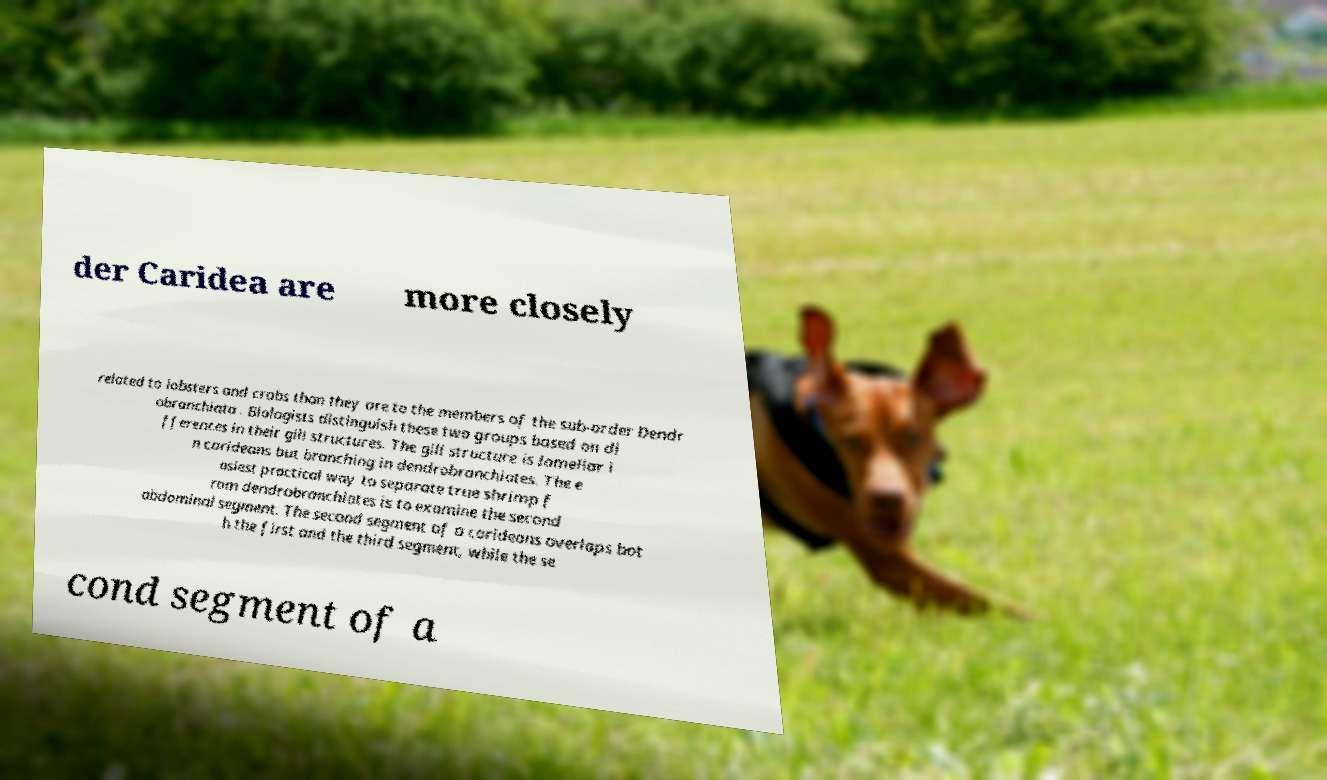For documentation purposes, I need the text within this image transcribed. Could you provide that? der Caridea are more closely related to lobsters and crabs than they are to the members of the sub-order Dendr obranchiata . Biologists distinguish these two groups based on di fferences in their gill structures. The gill structure is lamellar i n carideans but branching in dendrobranchiates. The e asiest practical way to separate true shrimp f rom dendrobranchiates is to examine the second abdominal segment. The second segment of a carideans overlaps bot h the first and the third segment, while the se cond segment of a 